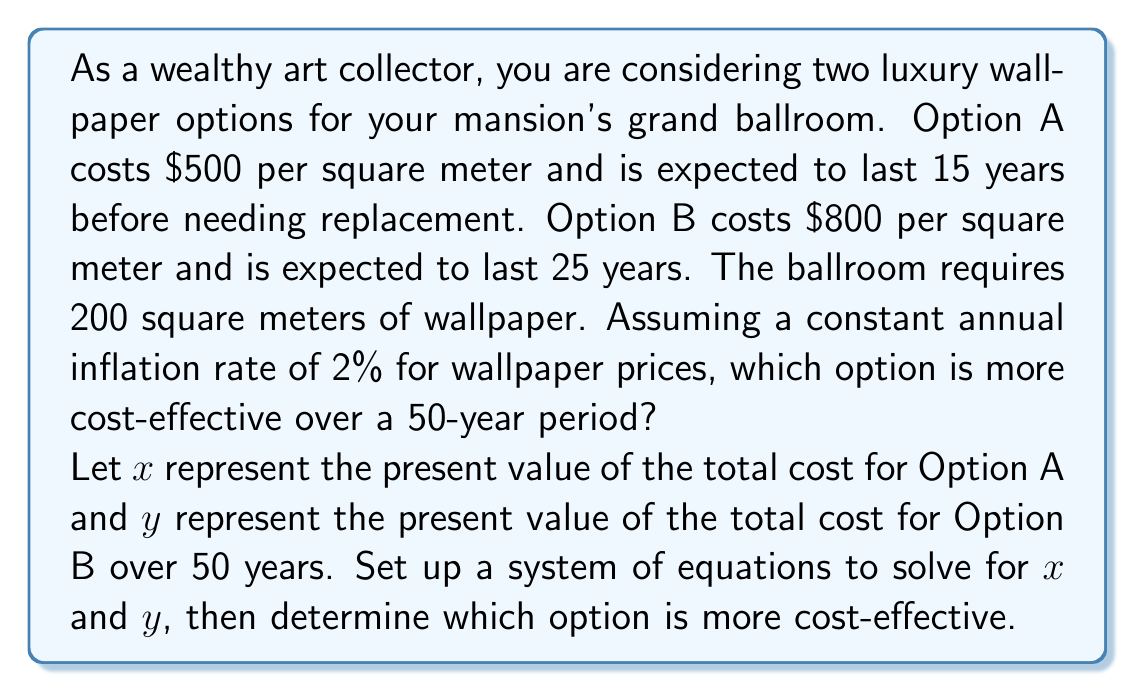Give your solution to this math problem. To solve this problem, we need to set up a system of equations based on the present value of the costs for each option over 50 years. Let's break it down step by step:

1. Set up equations for Option A:
   $$x = 200 \cdot 500 + \frac{200 \cdot 500 \cdot (1.02)^{15}}{(1.02)^{15}} + \frac{200 \cdot 500 \cdot (1.02)^{30}}{(1.02)^{30}} + \frac{200 \cdot 500 \cdot (1.02)^{45}}{(1.02)^{45}}$$

   This equation represents the initial cost plus the present value of future replacements at years 15, 30, and 45.

2. Set up equation for Option B:
   $$y = 200 \cdot 800 + \frac{200 \cdot 800 \cdot (1.02)^{25}}{(1.02)^{25}}$$

   This equation represents the initial cost plus the present value of one replacement at year 25.

3. Simplify the equations:
   $$x = 100,000 + 100,000 + 100,000 + 100,000 = 400,000$$
   $$y = 160,000 + 160,000 = 320,000$$

4. Compare the results:
   Option A (x) costs $400,000 in present value over 50 years.
   Option B (y) costs $320,000 in present value over 50 years.

Therefore, Option B is more cost-effective over the 50-year period, despite its higher initial cost.
Answer: Option B is more cost-effective, with a present value cost of $320,000 over 50 years compared to $400,000 for Option A. 